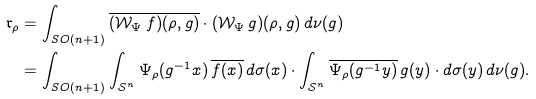<formula> <loc_0><loc_0><loc_500><loc_500>\mathfrak r _ { \rho } & = \int _ { S O ( n + 1 ) } \overline { ( \mathcal { W } _ { \Psi } \, f ) ( \rho , g ) } \cdot ( \mathcal { W } _ { \Psi } \, g ) ( \rho , g ) \, d \nu ( g ) \\ & = \int _ { S O ( n + 1 ) } \int _ { \mathcal { S } ^ { n } } \Psi _ { \rho } ( g ^ { - 1 } x ) \, \overline { f ( x ) } \, d \sigma ( x ) \cdot \int _ { \mathcal { S } ^ { n } } \overline { \Psi _ { \rho } ( g ^ { - 1 } y ) } \, g ( y ) \cdot d \sigma ( y ) \, d \nu ( g ) .</formula> 